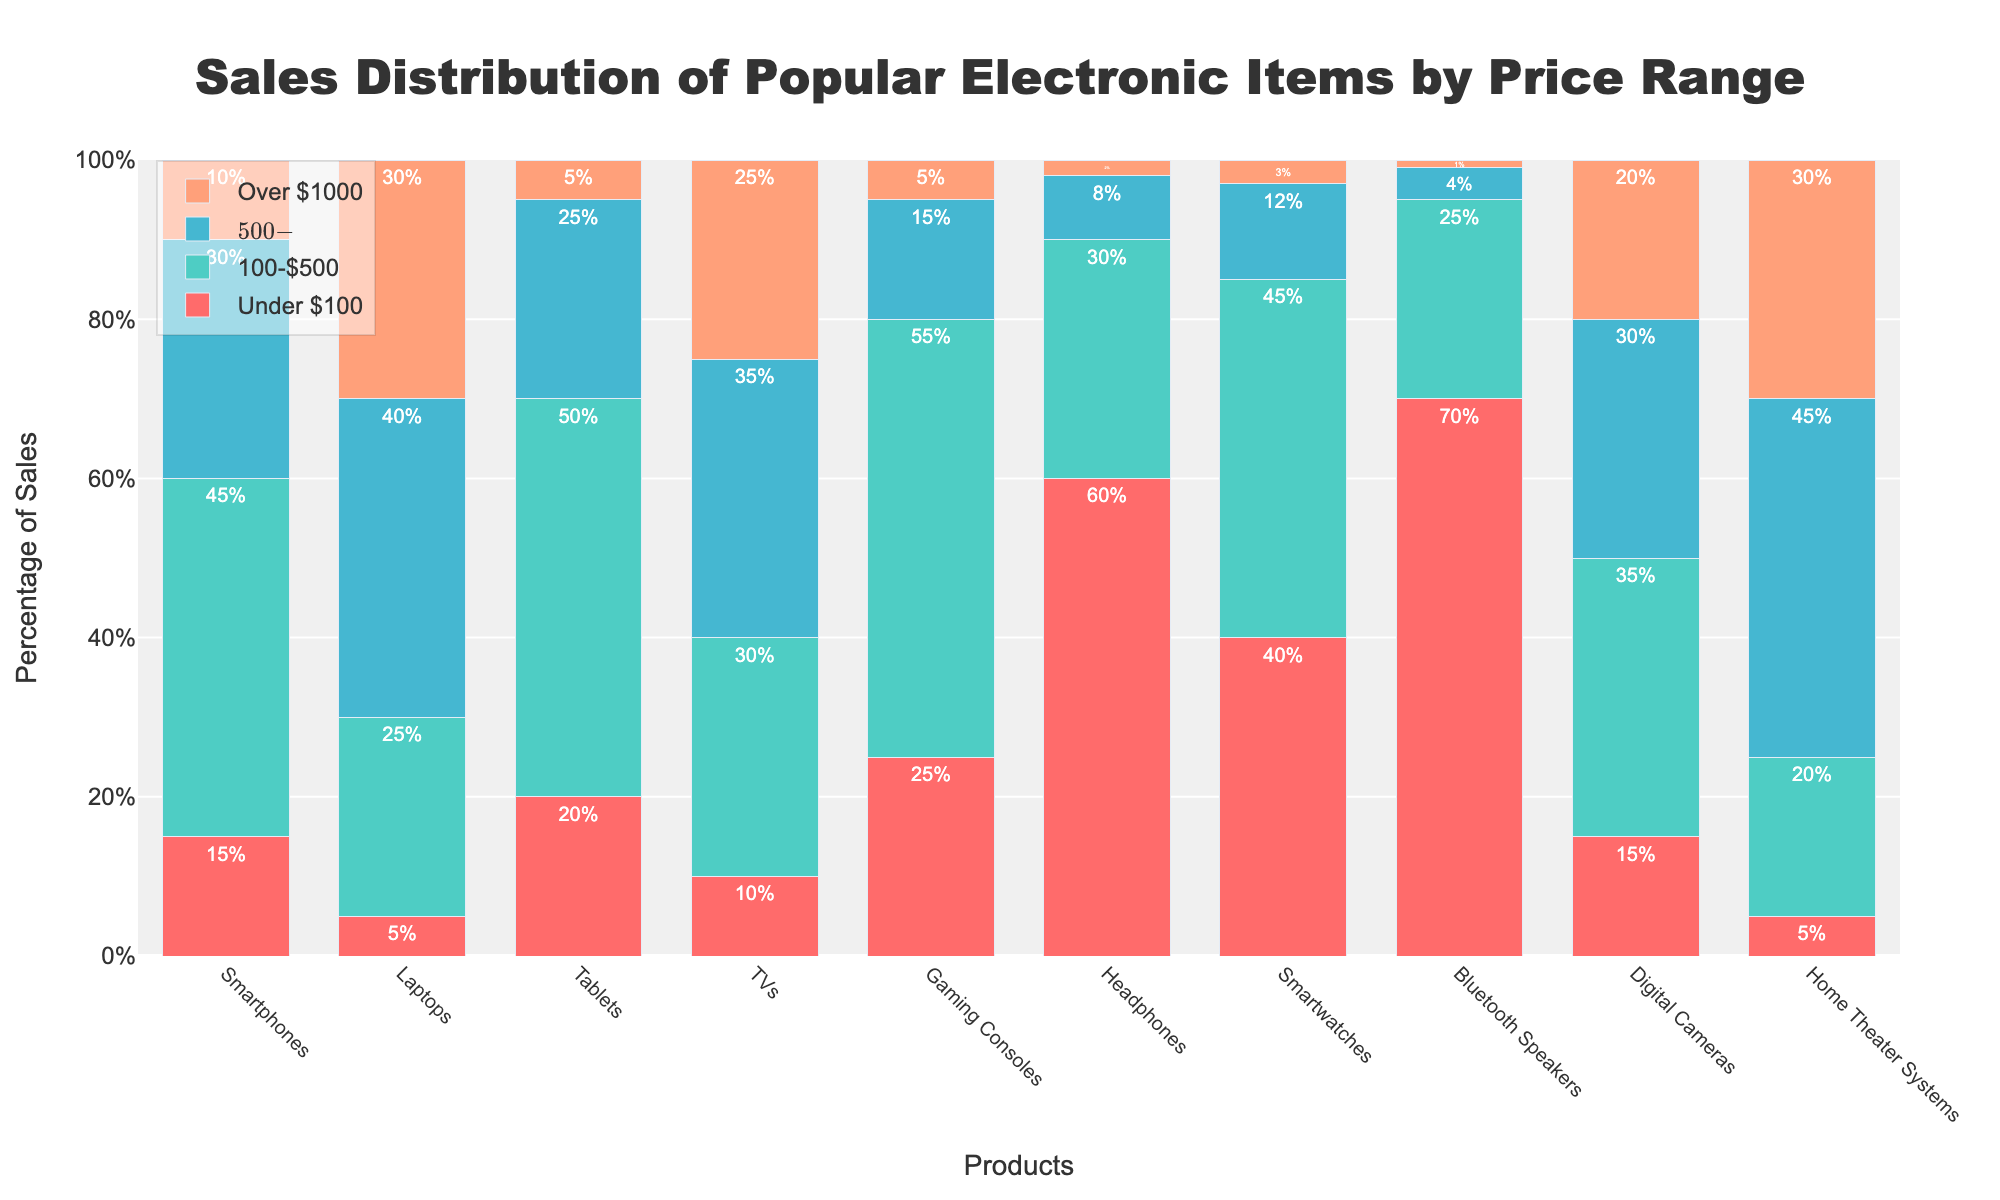Which product has the highest percentage of sales under $100? The tallest bar in the "Under $100" price range category is for Bluetooth Speakers, which corresponds to 70%.
Answer: Bluetooth Speakers Which product has the lowest percentage of sales in the $500-$1000 range? The shortest bar in the "$500-$1000" price range category is for Bluetooth Speakers, which is 4%.
Answer: Bluetooth Speakers Compare the percentage of sales for Smartphones and Laptops in the $100-$500 range. Which is higher? The bar for Smartphones in the "$100-$500" price range is at 45%, and the bar for Laptops is at 25%. 45% is higher than 25%.
Answer: Smartphones Sum up the percentage of sales for Headphones in the "Under $100" and "$100-$500" ranges. Headphones have 60% of sales "Under $100" and 30% in the "$100-$500" range. Their sum is 60% + 30% = 90%.
Answer: 90% Calculate the difference in the percentage of sales for Tablets and Gaming Consoles in the "$500-$1000" range. Tablets have 25% of sales in the "$500-$1000" range, while Gaming Consoles have 15%. The difference is 25% - 15% = 10%.
Answer: 10% Which product has the most evenly distributed sales across all price ranges? Home Theater Systems show relatively balanced bars across all categories with percentages of 5%, 20%, 45%, and 30%, respectively.
Answer: Home Theater Systems What is the highest percentage of sales in the "Over $1000" price range and which product does it correspond to? The highest bar in the "Over $1000" price range is for Laptops, which is at 30%.
Answer: Laptops Is the percentage of sales for Smartwatches higher or lower than that of Smartwatches in the "Under $100" range? The bar for Smartwatches in the "Under $100" range is 40%, whereas Headphones in the same category are at 60%. 40% is lower than 60%.
Answer: Lower How do the sales percentages for TVs compare between the $500-$1000 and Over $1000 price ranges? TVs have 35% of sales in the $500-$1000 range and 25% in the Over $1000 range. Comparing them, 35% is higher than 25%.
Answer: Higher in $500-$1000 Does any product have a higher percentage of sales in the "Under $100" category than Smartwatches in the $100-$500 range? Bluetooth Speakers have 70% of sales in "Under $100" and this is higher than the 45% of Smartwatches in the $100-$500 range.
Answer: Yes 